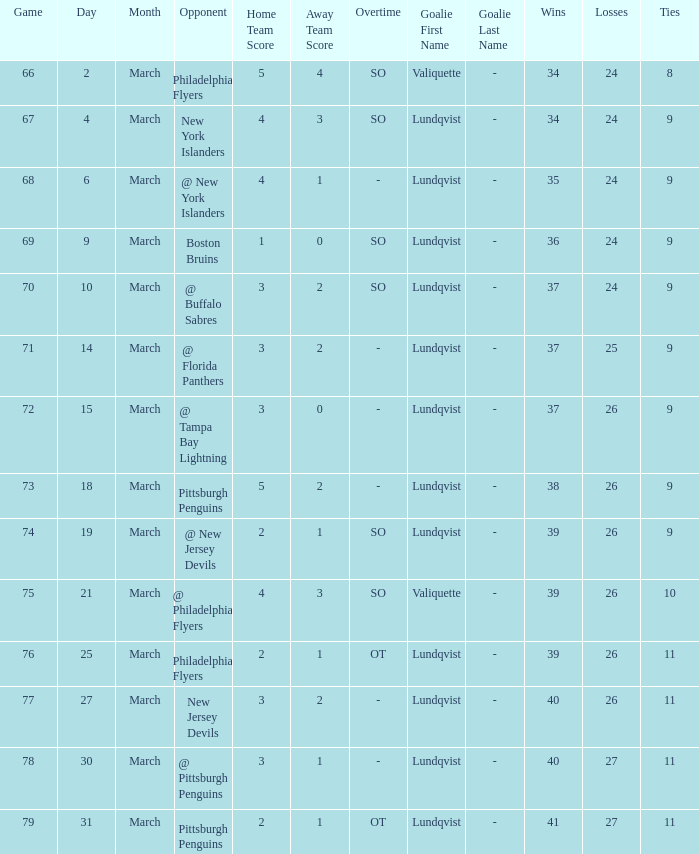Which score's game was less than 69 when the march was bigger than 2 and the opponents were the New York Islanders? 4 - 3 SO. 